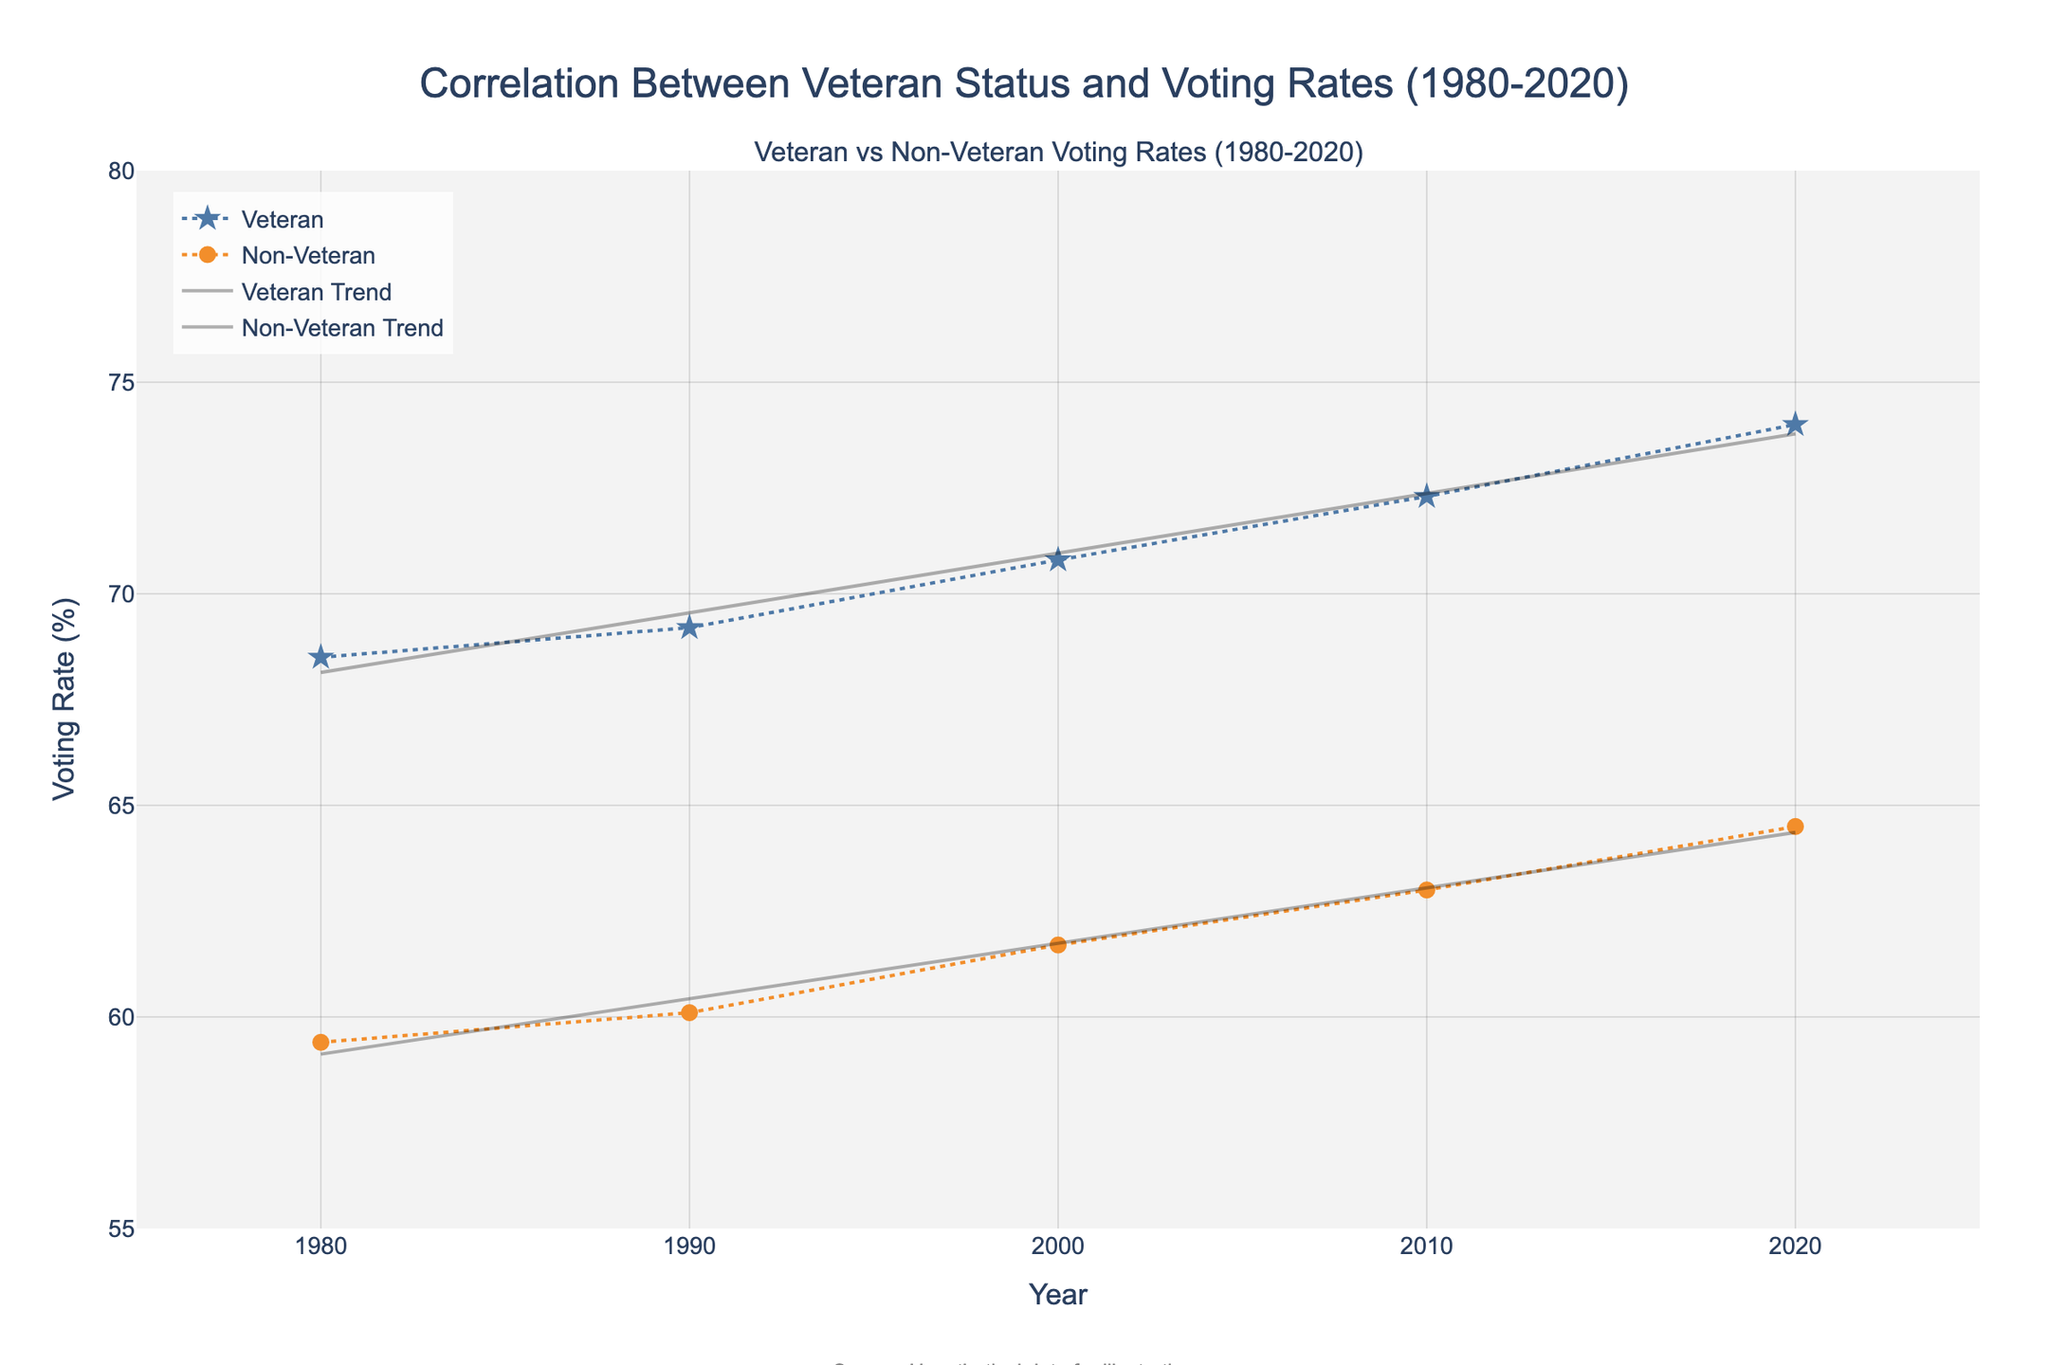What is the title of the figure? The title of the figure can be found at the top of the plot. The title is "Correlation Between Veteran Status and Voting Rates (1980-2020)."
Answer: Correlation Between Veteran Status and Voting Rates (1980-2020) How many years are displayed on the x-axis? The x-axis shows the years from 1980 to 2020 in increments of 10 years, totaling 5 years of data.
Answer: 5 Which group had a higher voting rate in 1990? By comparing the markers for 1990, we see that the voting rate for Veterans was higher (69.2%) compared to Non-Veterans (60.1%).
Answer: Veterans What is the trend for Veteran voting rates from 1980 to 2020? The scatter plot with trend lines indicates an upward trend for Veteran voting rates over the years, rising from approximately 68.5% in 1980 to 74.0% in 2020.
Answer: Upward trend What's the difference in voting rates between Veterans and Non-Veterans in 2020? In 2020, the voting rate for Veterans is 74.0%, while for Non-Veterans it is 64.5%. The difference is calculated as 74.0 - 64.5 = 9.5%.
Answer: 9.5% How has the Non-Veteran voting rate changed from 2000 to 2010? Observing the Non-Veteran data points, the voting rate increased from 61.7% in 2000 to 63.0% in 2010. The change is 63.0 - 61.7 = 1.3%.
Answer: Increased by 1.3% Which group shows a steeper increase in voting rates, according to the trend lines? The trend lines slope can be inferred from the gradients; Veterans show a steeper increase, as indicated by a higher rise in voting rates compared to Non-Veterans over the same time period.
Answer: Veterans What symbols are used to represent Veterans and Non-Veterans? The markers for Veterans are stars and are colored blue, while Non-Veterans are represented by circles colored orange.
Answer: Stars for Veterans, Circles for Non-Veterans What do the trend lines suggest about the future voting rates if the trends continue? The trend lines for both groups indicate an upward trajectory. If these trends continue, we can expect both Veteran and Non-Veteran voting rates to keep increasing in future decades.
Answer: Both will increase further What is the range of voting rates displayed on the y-axis? The y-axis ranges from 55% to 80% as indicated by the scale.
Answer: 55% to 80% 